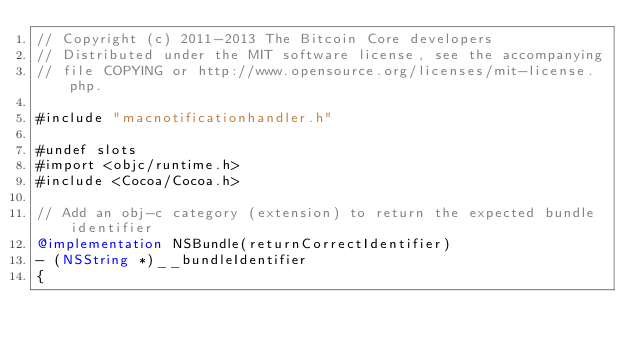<code> <loc_0><loc_0><loc_500><loc_500><_ObjectiveC_>// Copyright (c) 2011-2013 The Bitcoin Core developers
// Distributed under the MIT software license, see the accompanying
// file COPYING or http://www.opensource.org/licenses/mit-license.php.

#include "macnotificationhandler.h"

#undef slots
#import <objc/runtime.h>
#include <Cocoa/Cocoa.h>

// Add an obj-c category (extension) to return the expected bundle identifier
@implementation NSBundle(returnCorrectIdentifier)
- (NSString *)__bundleIdentifier
{</code> 